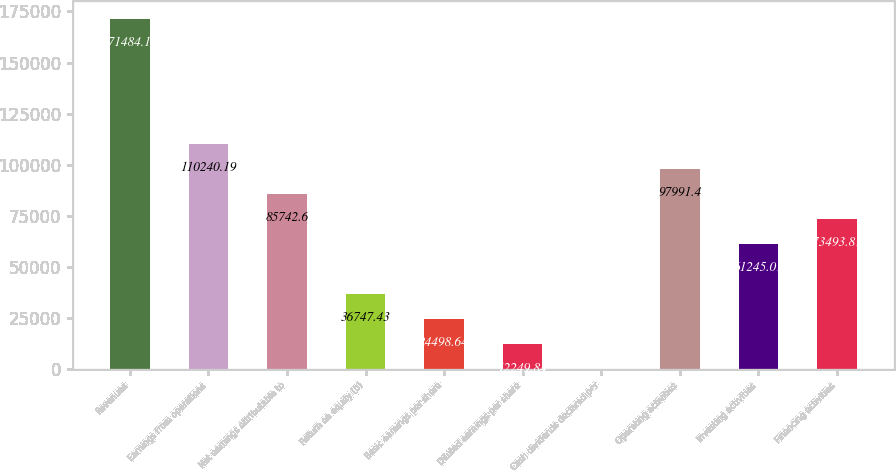Convert chart. <chart><loc_0><loc_0><loc_500><loc_500><bar_chart><fcel>Revenues<fcel>Earnings from operations<fcel>Net earnings attributable to<fcel>Return on equity (b)<fcel>Basic earnings per share<fcel>Diluted earnings per share<fcel>Cash dividends declared per<fcel>Operating activities<fcel>Investing activities<fcel>Financing activities<nl><fcel>171484<fcel>110240<fcel>85742.6<fcel>36747.4<fcel>24498.6<fcel>12249.8<fcel>1.05<fcel>97991.4<fcel>61245<fcel>73493.8<nl></chart> 